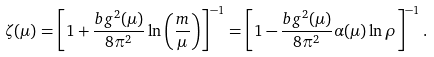Convert formula to latex. <formula><loc_0><loc_0><loc_500><loc_500>\zeta ( \mu ) = \left [ 1 + \frac { b g ^ { 2 } ( \mu ) } { 8 \pi ^ { 2 } } \ln \left ( \frac { m } { \mu } \right ) \right ] ^ { - 1 } = \left [ 1 - \frac { b g ^ { 2 } ( \mu ) } { 8 \pi ^ { 2 } } \alpha ( \mu ) \ln \rho \right ] ^ { - 1 } .</formula> 